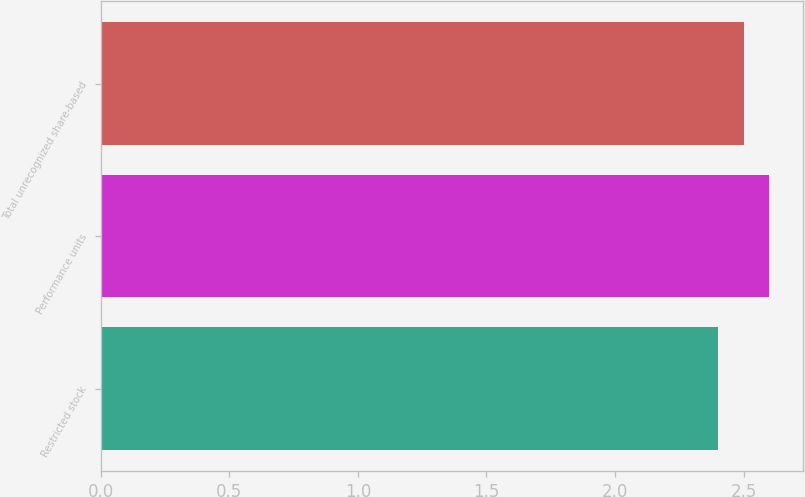<chart> <loc_0><loc_0><loc_500><loc_500><bar_chart><fcel>Restricted stock<fcel>Performance units<fcel>Total unrecognized share-based<nl><fcel>2.4<fcel>2.6<fcel>2.5<nl></chart> 